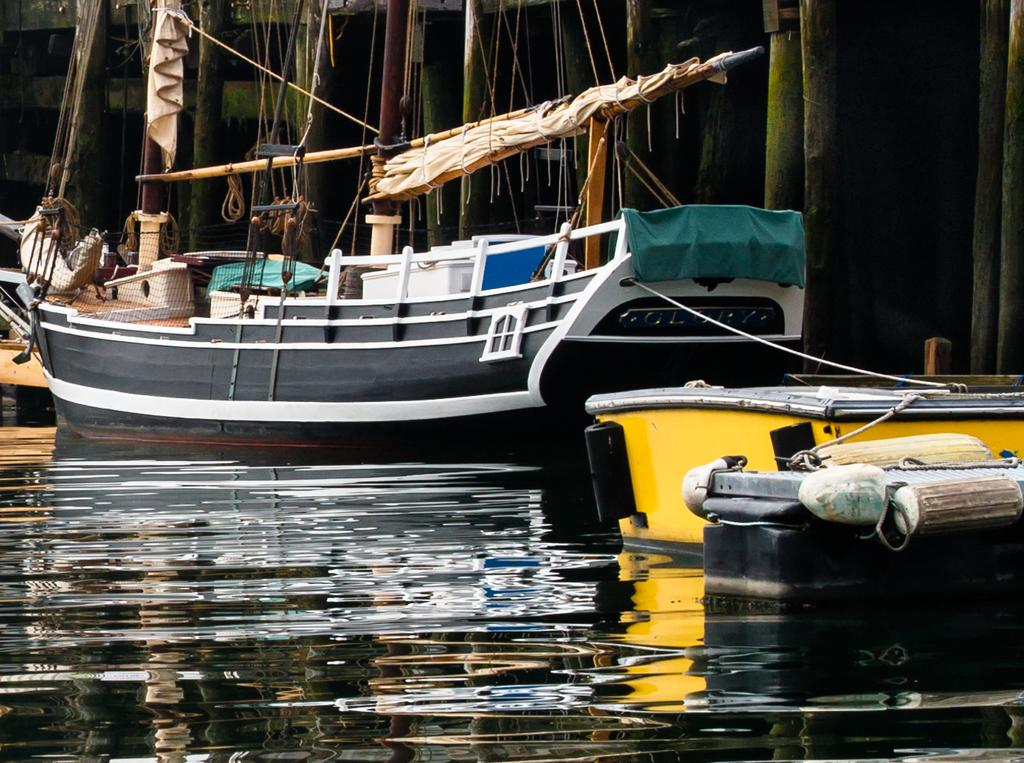What type of vehicles are in the image? There are boats in the image. Where are the boats located? The boats are on the surface of water. Can you describe the color of the boats? One boat is yellow, and the other is black and white. What can be seen in the background of the image? Bamboo poles are present in the background of the image. What type of sofa can be seen in the image? There is no sofa present in the image; it features boats on the water with bamboo poles in the background. 